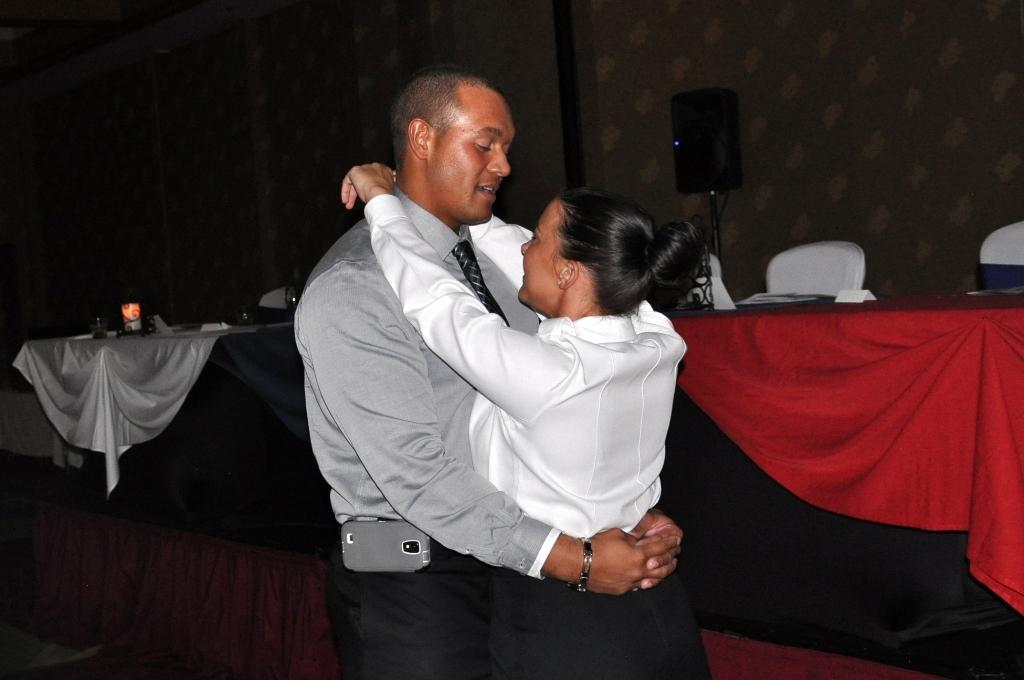How many people are the people are present in the image? There are two people, a man and a woman, present in the image. What are the man and woman doing in the image? The man and woman are hugging each other in the image. What type of furniture can be seen in the image? There are chairs and tables in the image. What type of grass is growing on the chairs in the image? There is no grass present in the image; it features a man and a woman hugging each other, along with chairs and tables. 